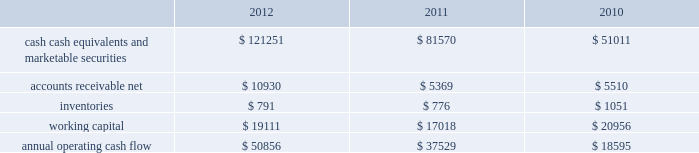35% ( 35 % ) due primarily to certain undistributed foreign earnings for which no u.s .
Taxes are provided because such earnings are intended to be indefinitely reinvested outside the u.s .
As of september 29 , 2012 , the company had deferred tax assets arising from deductible temporary differences , tax losses , and tax credits of $ 4.0 billion , and deferred tax liabilities of $ 14.9 billion .
Management believes it is more likely than not that forecasted income , including income that may be generated as a result of certain tax planning strategies , together with future reversals of existing taxable temporary differences , will be sufficient to fully recover the deferred tax assets .
The company will continue to evaluate the realizability of deferred tax assets quarterly by assessing the need for and amount of a valuation allowance .
The internal revenue service ( the 201cirs 201d ) has completed its field audit of the company 2019s federal income tax returns for the years 2004 through 2006 and proposed certain adjustments .
The company has contested certain of these adjustments through the irs appeals office .
The irs is currently examining the years 2007 through 2009 .
All irs audit issues for years prior to 2004 have been resolved .
In addition , the company is subject to audits by state , local , and foreign tax authorities .
Management believes that adequate provisions have been made for any adjustments that may result from tax examinations .
However , the outcome of tax audits cannot be predicted with certainty .
If any issues addressed in the company 2019s tax audits are resolved in a manner not consistent with management 2019s expectations , the company could be required to adjust its provision for income taxes in the period such resolution occurs .
Liquidity and capital resources the table presents selected financial information and statistics as of and for the years ended september 29 , 2012 , september 24 , 2011 , and september 25 , 2010 ( in millions ) : .
As of september 29 , 2012 , the company had $ 121.3 billion in cash , cash equivalents and marketable securities , an increase of $ 39.7 billion or 49% ( 49 % ) from september 24 , 2011 .
The principal components of this net increase was the cash generated by operating activities of $ 50.9 billion , which was partially offset by payments for acquisition of property , plant and equipment of $ 8.3 billion , payments for acquisition of intangible assets of $ 1.1 billion and payments of dividends and dividend equivalent rights of $ 2.5 billion .
The company 2019s marketable securities investment portfolio is invested primarily in highly-rated securities and its investment policy generally limits the amount of credit exposure to any one issuer .
The policy requires investments generally to be investment grade with the objective of minimizing the potential risk of principal loss .
As of september 29 , 2012 and september 24 , 2011 , $ 82.6 billion and $ 54.3 billion , respectively , of the company 2019s cash , cash equivalents and marketable securities were held by foreign subsidiaries and are generally based in u.s .
Dollar-denominated holdings .
Amounts held by foreign subsidiaries are generally subject to u.s .
Income taxation on repatriation to the u.s .
The company believes its existing balances of cash , cash equivalents and marketable securities will be sufficient to satisfy its working capital needs , capital asset purchases , outstanding commitments , common stock repurchases , dividends on its common stock , and other liquidity requirements associated with its existing operations over the next 12 months .
Capital assets the company 2019s capital expenditures were $ 10.3 billion during 2012 , consisting of $ 865 million for retail store facilities and $ 9.5 billion for other capital expenditures , including product tooling and manufacturing process .
What was the increase in annual operating cash flow between 2010 and 2012? 
Computations: (50856 - 18595)
Answer: 32261.0. 